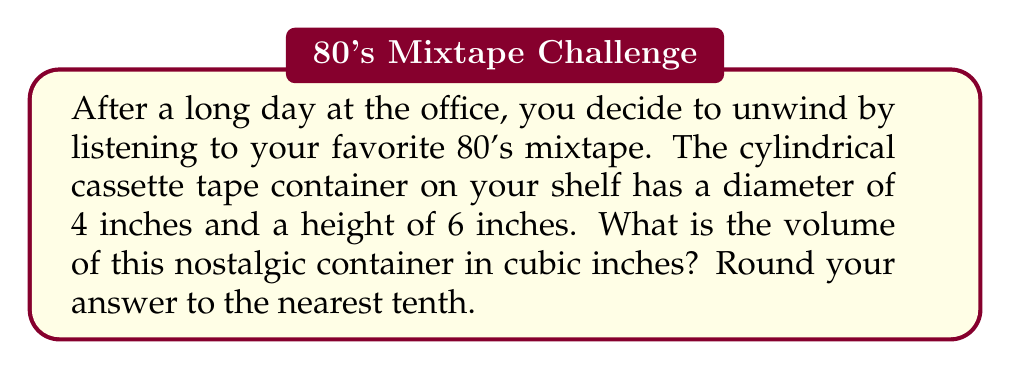What is the answer to this math problem? To solve this problem, we need to use the formula for the volume of a cylinder:

$$V = \pi r^2 h$$

Where:
$V$ = volume
$r$ = radius of the base
$h$ = height of the cylinder

Let's break it down step-by-step:

1. Identify the given information:
   - Diameter = 4 inches
   - Height = 6 inches

2. Calculate the radius:
   The radius is half the diameter.
   $r = 4 \div 2 = 2$ inches

3. Substitute the values into the formula:
   $$V = \pi (2\text{ in})^2 (6\text{ in})$$

4. Simplify:
   $$V = \pi (4\text{ in}^2) (6\text{ in})$$
   $$V = 24\pi \text{ in}^3$$

5. Calculate the result:
   $$V \approx 24 \times 3.14159 \text{ in}^3$$
   $$V \approx 75.39816 \text{ in}^3$$

6. Round to the nearest tenth:
   $$V \approx 75.4 \text{ in}^3$$

[asy]
import geometry;

size(200);
real r = 2;
real h = 6;

path base = circle((0,0), r);
path top = circle((0,h), r);

draw(base);
draw(top);
draw((r,0)--(r,h));
draw((-r,0)--(-r,h));

label("4\"", (0,-r), S);
label("6\"", (r+0.5,h/2), E);

[/asy]
Answer: The volume of the cylindrical cassette tape container is approximately 75.4 cubic inches. 